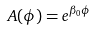<formula> <loc_0><loc_0><loc_500><loc_500>A ( \phi ) = e ^ { \beta _ { 0 } \phi }</formula> 